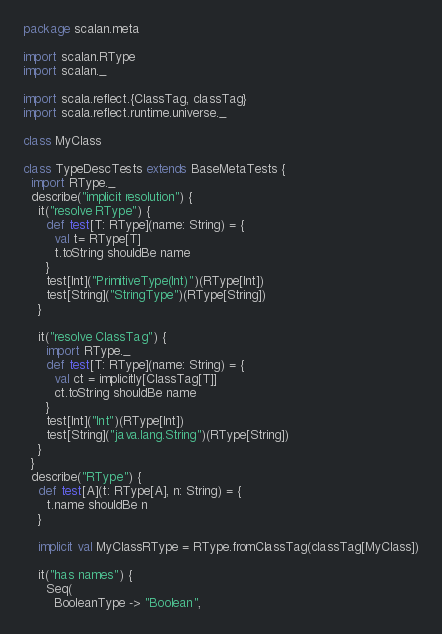Convert code to text. <code><loc_0><loc_0><loc_500><loc_500><_Scala_>package scalan.meta

import scalan.RType
import scalan._

import scala.reflect.{ClassTag, classTag}
import scala.reflect.runtime.universe._

class MyClass

class TypeDescTests extends BaseMetaTests {
  import RType._
  describe("implicit resolution") {
    it("resolve RType") {
      def test[T: RType](name: String) = {
        val t= RType[T]
        t.toString shouldBe name
      }
      test[Int]("PrimitiveType(Int)")(RType[Int])
      test[String]("StringType")(RType[String])
    }

    it("resolve ClassTag") {
      import RType._
      def test[T: RType](name: String) = {
        val ct = implicitly[ClassTag[T]]
        ct.toString shouldBe name
      }
      test[Int]("Int")(RType[Int])
      test[String]("java.lang.String")(RType[String])
    }
  }
  describe("RType") {
    def test[A](t: RType[A], n: String) = {
      t.name shouldBe n
    }

    implicit val MyClassRType = RType.fromClassTag(classTag[MyClass])

    it("has names") {
      Seq(
        BooleanType -> "Boolean",</code> 